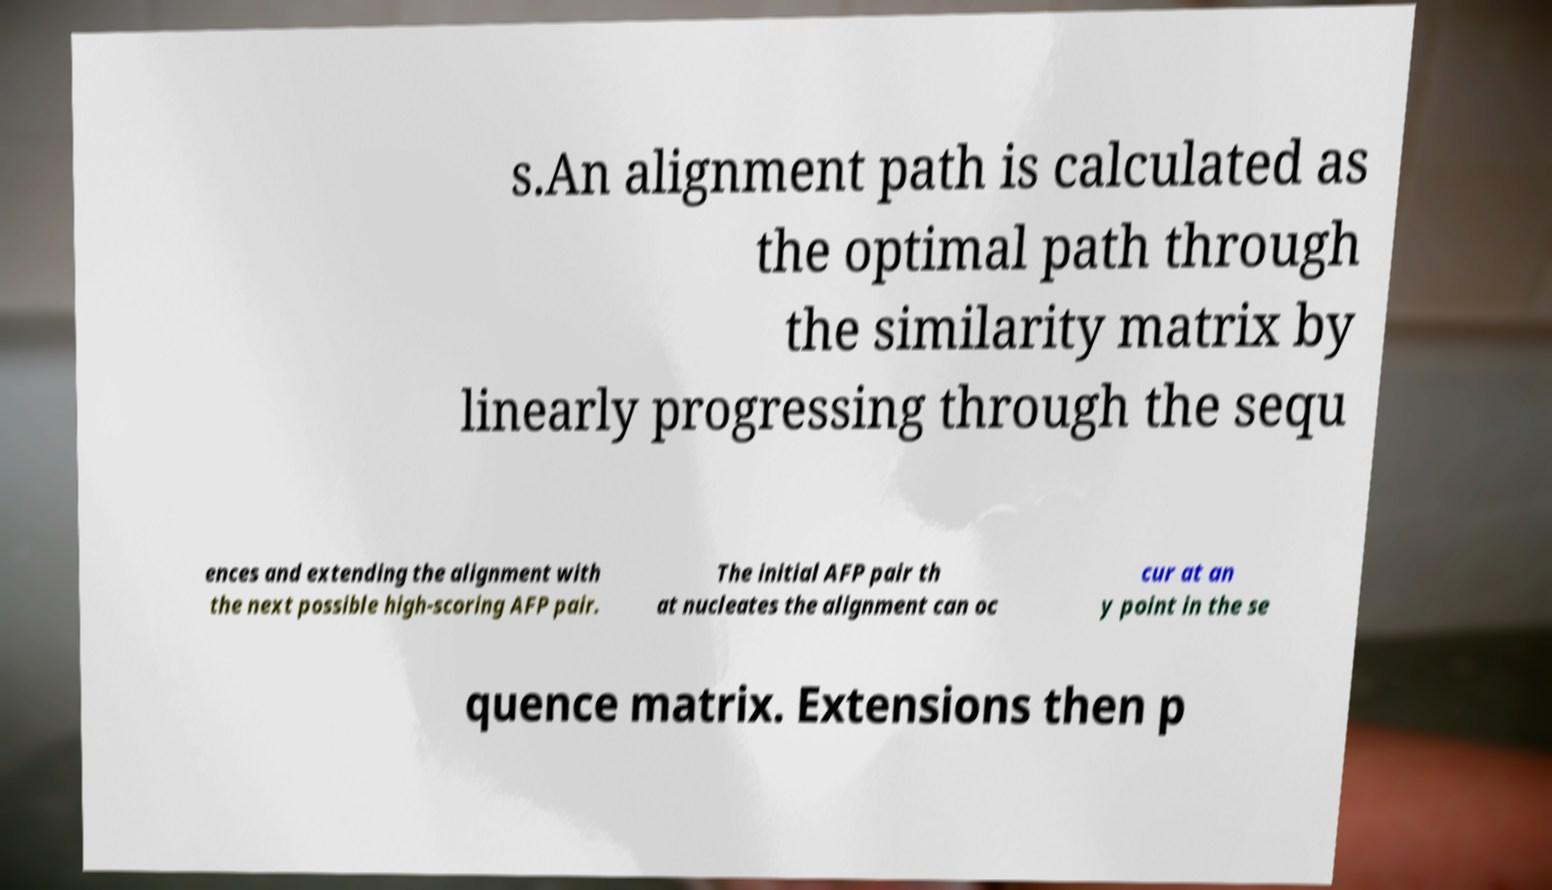I need the written content from this picture converted into text. Can you do that? s.An alignment path is calculated as the optimal path through the similarity matrix by linearly progressing through the sequ ences and extending the alignment with the next possible high-scoring AFP pair. The initial AFP pair th at nucleates the alignment can oc cur at an y point in the se quence matrix. Extensions then p 